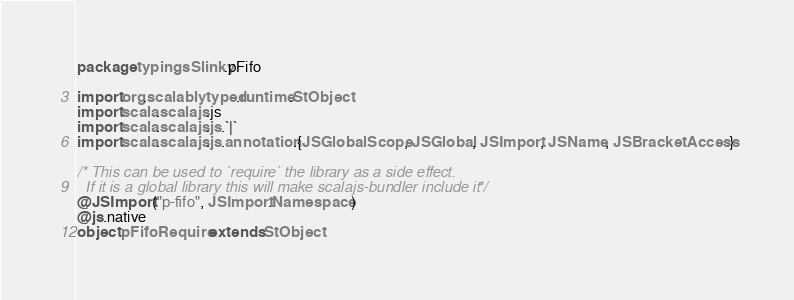<code> <loc_0><loc_0><loc_500><loc_500><_Scala_>package typingsSlinky.pFifo

import org.scalablytyped.runtime.StObject
import scala.scalajs.js
import scala.scalajs.js.`|`
import scala.scalajs.js.annotation.{JSGlobalScope, JSGlobal, JSImport, JSName, JSBracketAccess}

/* This can be used to `require` the library as a side effect.
  If it is a global library this will make scalajs-bundler include it */
@JSImport("p-fifo", JSImport.Namespace)
@js.native
object pFifoRequire extends StObject
</code> 